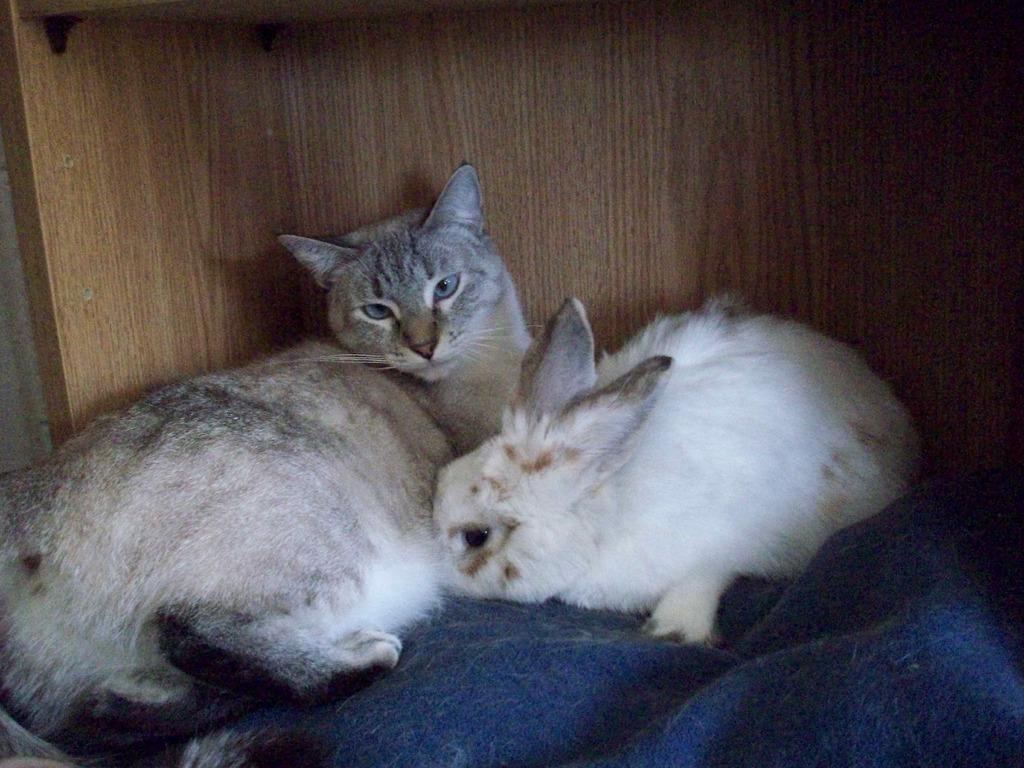Could you give a brief overview of what you see in this image? In this picture we see a cat and a rabbit sitting in something. 